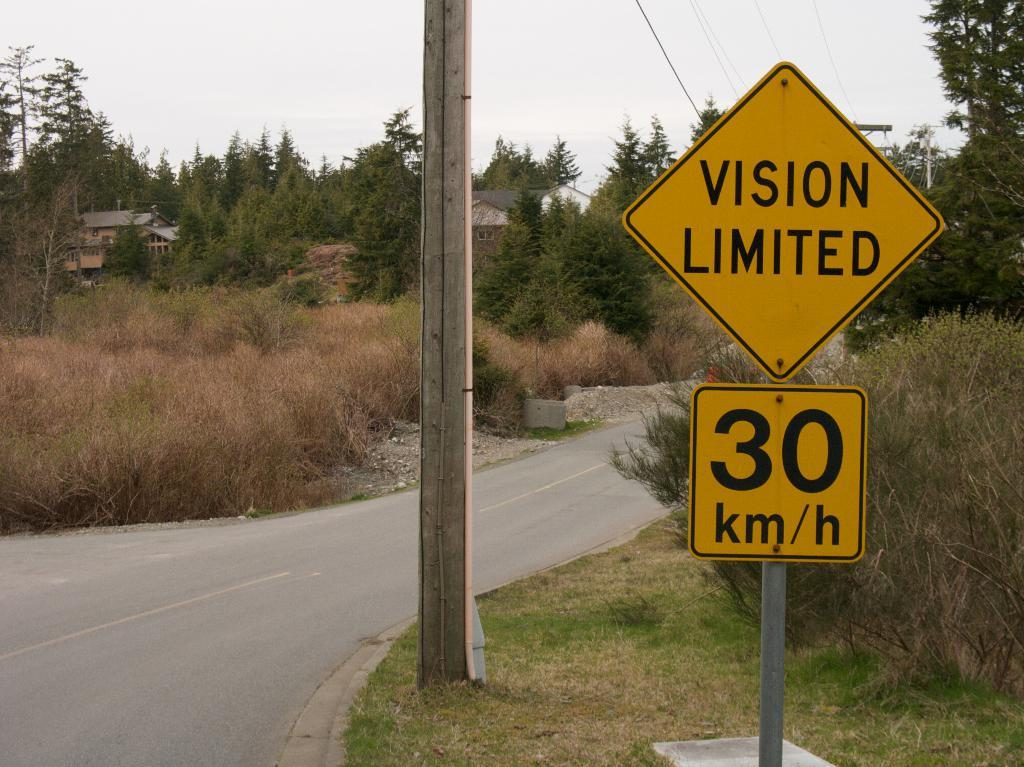<image>
Write a terse but informative summary of the picture. A yellow road sign says that vision is limited. 